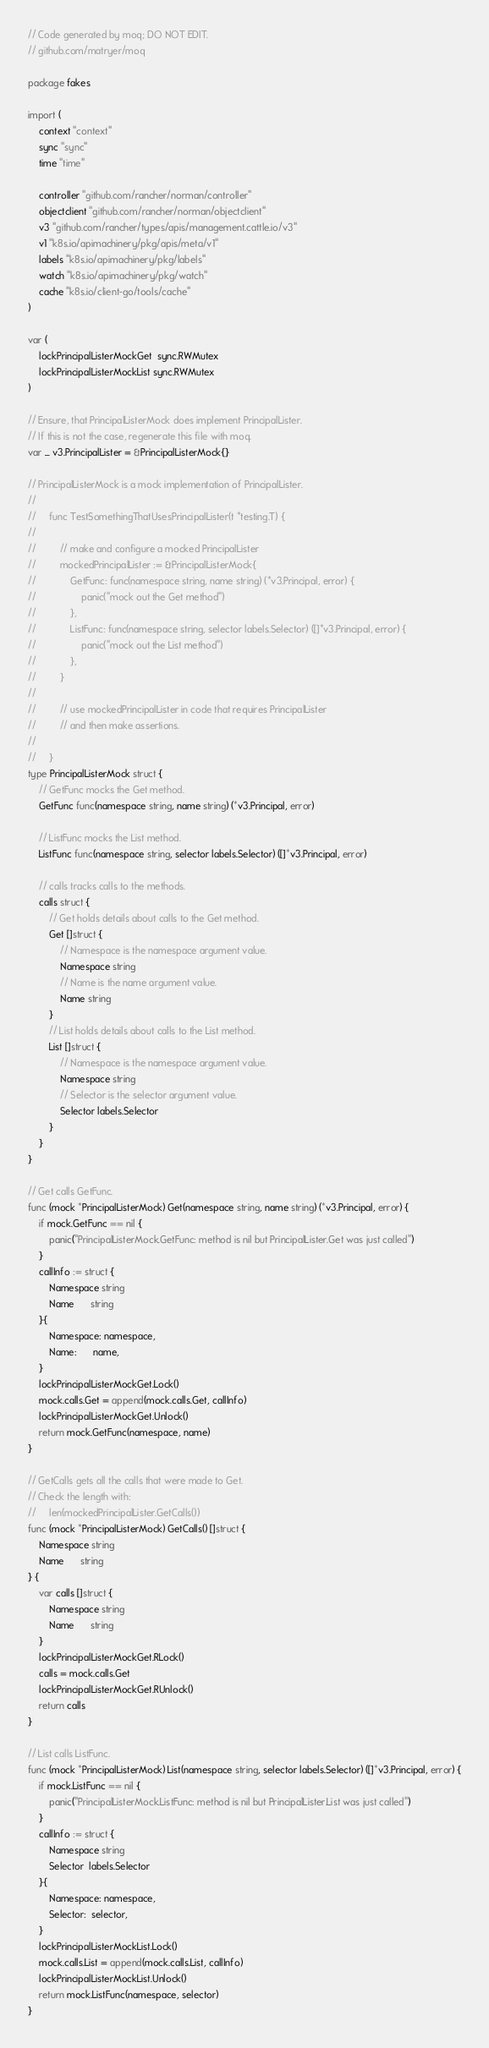Convert code to text. <code><loc_0><loc_0><loc_500><loc_500><_Go_>// Code generated by moq; DO NOT EDIT.
// github.com/matryer/moq

package fakes

import (
	context "context"
	sync "sync"
	time "time"

	controller "github.com/rancher/norman/controller"
	objectclient "github.com/rancher/norman/objectclient"
	v3 "github.com/rancher/types/apis/management.cattle.io/v3"
	v1 "k8s.io/apimachinery/pkg/apis/meta/v1"
	labels "k8s.io/apimachinery/pkg/labels"
	watch "k8s.io/apimachinery/pkg/watch"
	cache "k8s.io/client-go/tools/cache"
)

var (
	lockPrincipalListerMockGet  sync.RWMutex
	lockPrincipalListerMockList sync.RWMutex
)

// Ensure, that PrincipalListerMock does implement PrincipalLister.
// If this is not the case, regenerate this file with moq.
var _ v3.PrincipalLister = &PrincipalListerMock{}

// PrincipalListerMock is a mock implementation of PrincipalLister.
//
//     func TestSomethingThatUsesPrincipalLister(t *testing.T) {
//
//         // make and configure a mocked PrincipalLister
//         mockedPrincipalLister := &PrincipalListerMock{
//             GetFunc: func(namespace string, name string) (*v3.Principal, error) {
// 	               panic("mock out the Get method")
//             },
//             ListFunc: func(namespace string, selector labels.Selector) ([]*v3.Principal, error) {
// 	               panic("mock out the List method")
//             },
//         }
//
//         // use mockedPrincipalLister in code that requires PrincipalLister
//         // and then make assertions.
//
//     }
type PrincipalListerMock struct {
	// GetFunc mocks the Get method.
	GetFunc func(namespace string, name string) (*v3.Principal, error)

	// ListFunc mocks the List method.
	ListFunc func(namespace string, selector labels.Selector) ([]*v3.Principal, error)

	// calls tracks calls to the methods.
	calls struct {
		// Get holds details about calls to the Get method.
		Get []struct {
			// Namespace is the namespace argument value.
			Namespace string
			// Name is the name argument value.
			Name string
		}
		// List holds details about calls to the List method.
		List []struct {
			// Namespace is the namespace argument value.
			Namespace string
			// Selector is the selector argument value.
			Selector labels.Selector
		}
	}
}

// Get calls GetFunc.
func (mock *PrincipalListerMock) Get(namespace string, name string) (*v3.Principal, error) {
	if mock.GetFunc == nil {
		panic("PrincipalListerMock.GetFunc: method is nil but PrincipalLister.Get was just called")
	}
	callInfo := struct {
		Namespace string
		Name      string
	}{
		Namespace: namespace,
		Name:      name,
	}
	lockPrincipalListerMockGet.Lock()
	mock.calls.Get = append(mock.calls.Get, callInfo)
	lockPrincipalListerMockGet.Unlock()
	return mock.GetFunc(namespace, name)
}

// GetCalls gets all the calls that were made to Get.
// Check the length with:
//     len(mockedPrincipalLister.GetCalls())
func (mock *PrincipalListerMock) GetCalls() []struct {
	Namespace string
	Name      string
} {
	var calls []struct {
		Namespace string
		Name      string
	}
	lockPrincipalListerMockGet.RLock()
	calls = mock.calls.Get
	lockPrincipalListerMockGet.RUnlock()
	return calls
}

// List calls ListFunc.
func (mock *PrincipalListerMock) List(namespace string, selector labels.Selector) ([]*v3.Principal, error) {
	if mock.ListFunc == nil {
		panic("PrincipalListerMock.ListFunc: method is nil but PrincipalLister.List was just called")
	}
	callInfo := struct {
		Namespace string
		Selector  labels.Selector
	}{
		Namespace: namespace,
		Selector:  selector,
	}
	lockPrincipalListerMockList.Lock()
	mock.calls.List = append(mock.calls.List, callInfo)
	lockPrincipalListerMockList.Unlock()
	return mock.ListFunc(namespace, selector)
}
</code> 